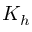<formula> <loc_0><loc_0><loc_500><loc_500>K _ { h }</formula> 